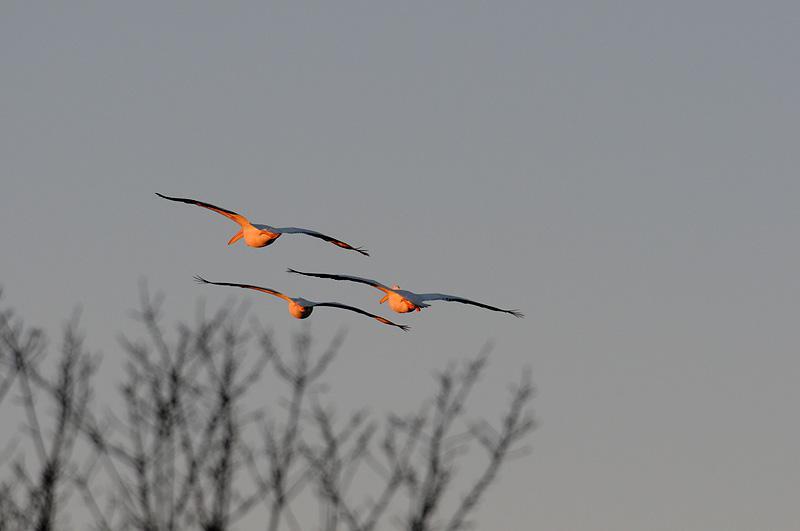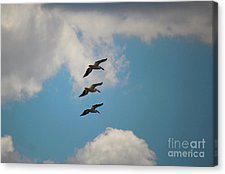The first image is the image on the left, the second image is the image on the right. Analyze the images presented: Is the assertion "There are no more than 4 pelicans." valid? Answer yes or no. No. The first image is the image on the left, the second image is the image on the right. Considering the images on both sides, is "AT least 2 black and white pelicans are flying to the right." valid? Answer yes or no. No. 